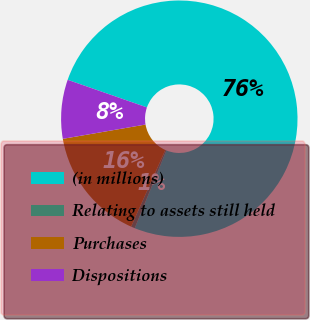Convert chart. <chart><loc_0><loc_0><loc_500><loc_500><pie_chart><fcel>(in millions)<fcel>Relating to assets still held<fcel>Purchases<fcel>Dispositions<nl><fcel>75.83%<fcel>0.53%<fcel>15.59%<fcel>8.06%<nl></chart> 